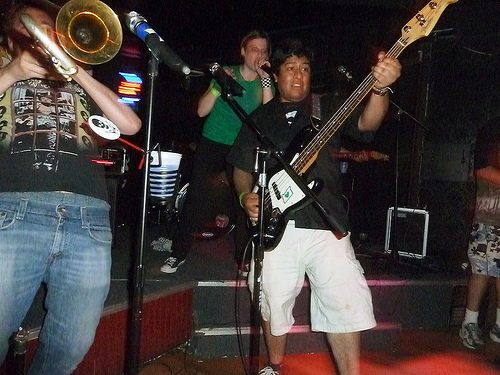<image>
Is the cup on the stage? Yes. Looking at the image, I can see the cup is positioned on top of the stage, with the stage providing support. 